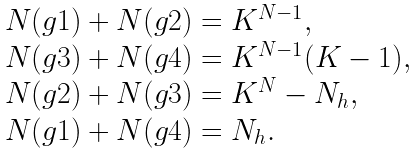Convert formula to latex. <formula><loc_0><loc_0><loc_500><loc_500>\begin{array} { l l } N ( g 1 ) + N ( g 2 ) = K ^ { N - 1 } , \\ N ( g 3 ) + N ( g 4 ) = K ^ { N - 1 } ( K - 1 ) , \\ N ( g 2 ) + N ( g 3 ) = K ^ { N } - N _ { h } , \\ N ( g 1 ) + N ( g 4 ) = N _ { h } . \end{array}</formula> 